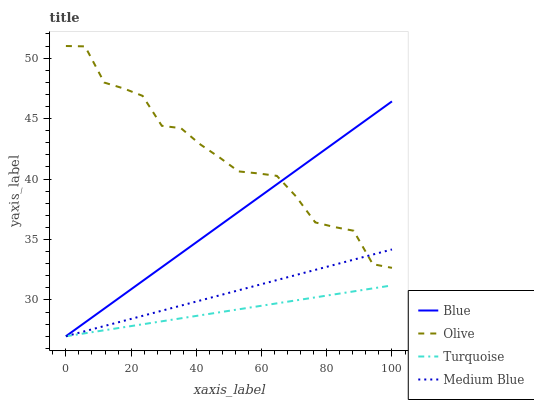Does Turquoise have the minimum area under the curve?
Answer yes or no. Yes. Does Olive have the maximum area under the curve?
Answer yes or no. Yes. Does Olive have the minimum area under the curve?
Answer yes or no. No. Does Turquoise have the maximum area under the curve?
Answer yes or no. No. Is Turquoise the smoothest?
Answer yes or no. Yes. Is Olive the roughest?
Answer yes or no. Yes. Is Olive the smoothest?
Answer yes or no. No. Is Turquoise the roughest?
Answer yes or no. No. Does Olive have the lowest value?
Answer yes or no. No. Does Olive have the highest value?
Answer yes or no. Yes. Does Turquoise have the highest value?
Answer yes or no. No. Is Turquoise less than Olive?
Answer yes or no. Yes. Is Olive greater than Turquoise?
Answer yes or no. Yes. Does Turquoise intersect Olive?
Answer yes or no. No. 